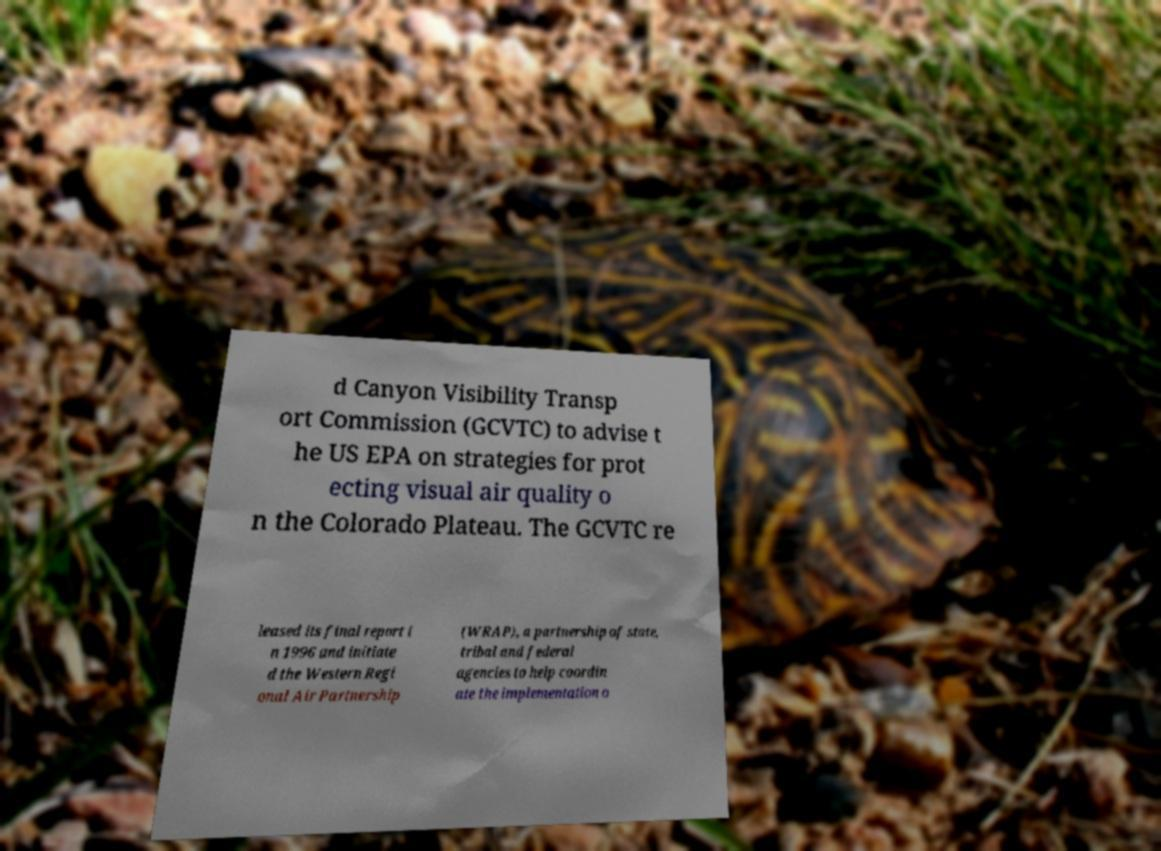For documentation purposes, I need the text within this image transcribed. Could you provide that? d Canyon Visibility Transp ort Commission (GCVTC) to advise t he US EPA on strategies for prot ecting visual air quality o n the Colorado Plateau. The GCVTC re leased its final report i n 1996 and initiate d the Western Regi onal Air Partnership (WRAP), a partnership of state, tribal and federal agencies to help coordin ate the implementation o 